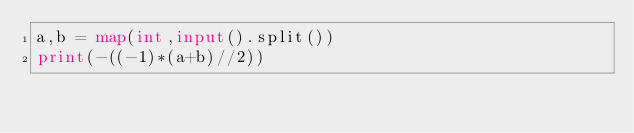<code> <loc_0><loc_0><loc_500><loc_500><_Python_>a,b = map(int,input().split())
print(-((-1)*(a+b)//2))
</code> 